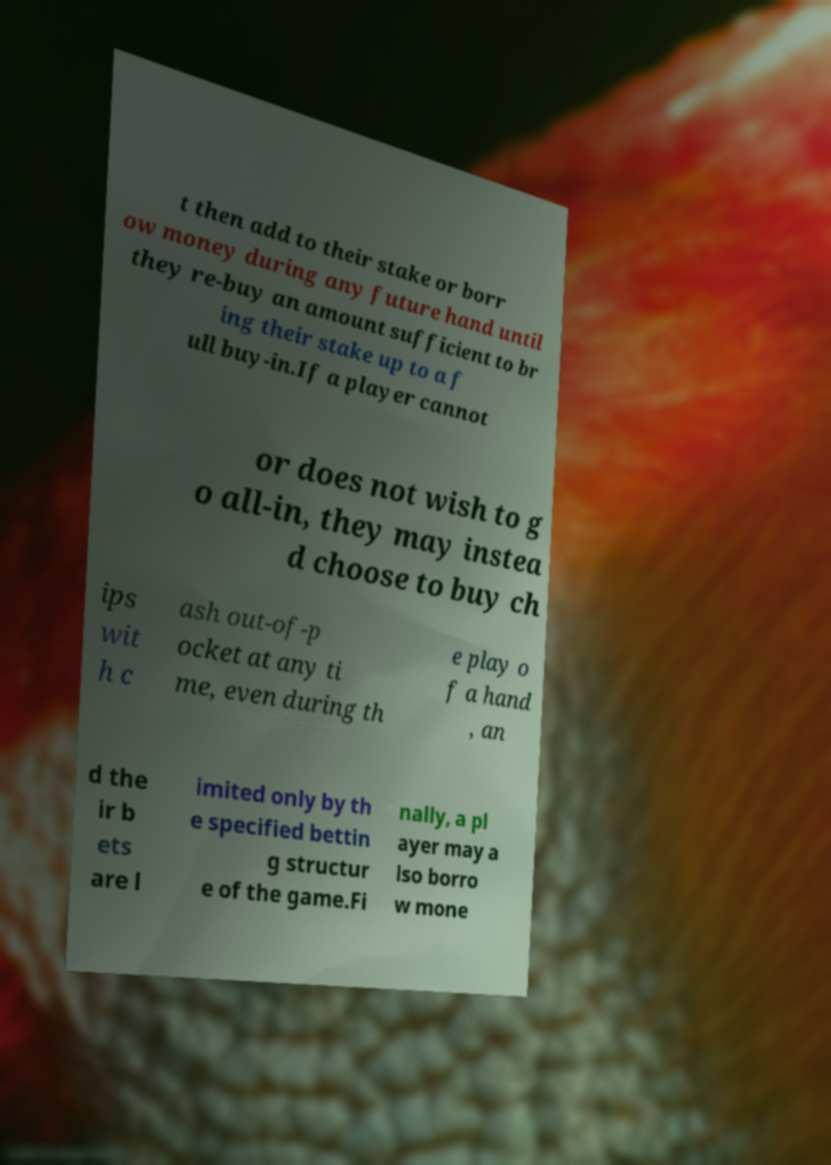Can you read and provide the text displayed in the image?This photo seems to have some interesting text. Can you extract and type it out for me? t then add to their stake or borr ow money during any future hand until they re-buy an amount sufficient to br ing their stake up to a f ull buy-in.If a player cannot or does not wish to g o all-in, they may instea d choose to buy ch ips wit h c ash out-of-p ocket at any ti me, even during th e play o f a hand , an d the ir b ets are l imited only by th e specified bettin g structur e of the game.Fi nally, a pl ayer may a lso borro w mone 